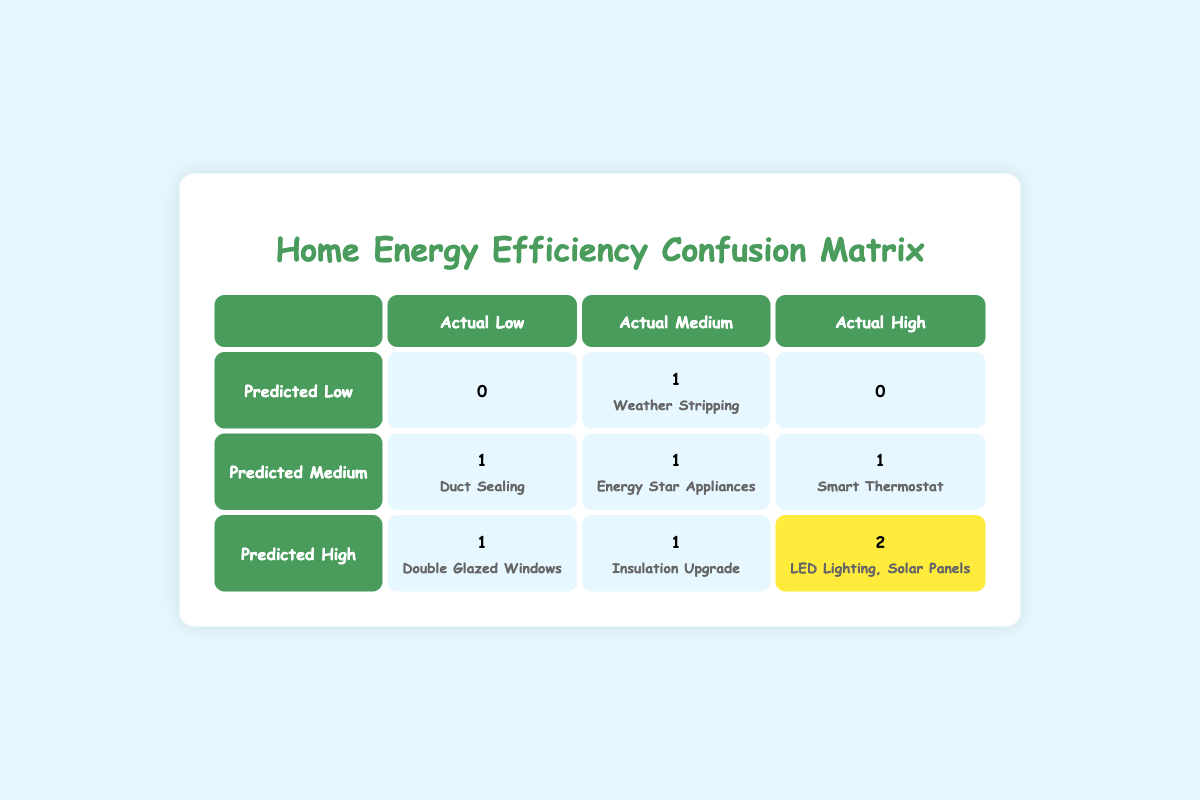What is the total number of upgrades predicted to have low actual savings? Referring to the table, we look at the "Predicted Low" row. The only entry with actual savings categorized as "Low" is "Duct Sealing," which means 1 upgrade is predicted to have low actual savings.
Answer: 1 Which upgrade has a predicted saving of medium but achieved high actual savings? By examining the "Predicted Medium" column, we find that "Smart Thermostat" has the predicted savings of "Medium" and actual savings of "High."
Answer: Smart Thermostat Are there any upgrades that resulted in high actual savings while being predicted to have low or medium savings? In the table, the only upgrades that have high actual savings are "LED Lighting" and "Solar Panels," both of which are categorized as having high predicted savings. Thus, there are no upgrades resulting in high actual savings while being predicted to have low or medium savings.
Answer: No What is the total count of upgrades that were predicted to have high savings? We observe the "Predicted High" row and count the instances: "Double Glazed Windows," "Insulation Upgrade," "LED Lighting," and "Solar Panels." This results in a total of 4 upgrades with high predicted savings.
Answer: 4 Which upgrade is the only one predicted to have low savings but achieved medium actual savings? Looking at the "Predicted Low" row, we can see "Weather Stripping" is the only upgrade that is categorized under low predicted savings and has medium actual savings.
Answer: Weather Stripping What is the difference between the number of upgrades that had a high prediction and actually achieved high savings compared to those that were predicted to have medium savings and achieved high savings? Counting the "Predicted High" row with actual "High," we have "LED Lighting" and "Solar Panels" (2 upgrades). In the "Predicted Medium" row with actual "High," we have "Smart Thermostat" (1 upgrade). The difference is 2 - 1 = 1.
Answer: 1 Did any upgrades fail to meet their predicted savings? In the table, the "Insulation Upgrade" is predicted to have high savings but only achieved medium savings, and "Double Glazed Windows" is predicted to have high savings but achieved low savings. Hence, there are indeed upgrades that failed to meet their predicted savings.
Answer: Yes What is the total number of upgrades that have medium actual savings? In reviewing the table, the upgrades that achieved medium actual savings are "Insulation Upgrade," "Energy Star Appliances," "Weather Stripping," and "Smart Thermostat." Therefore, the total count of such upgrades is 4.
Answer: 4 Which upgrade had the most significant discrepancy between predicted and actual savings? "Double Glazed Windows" is predicted to achieve high savings but only managed low savings, showcasing a significant drop from high to low. The discrepancy here is the largest.
Answer: Double Glazed Windows 